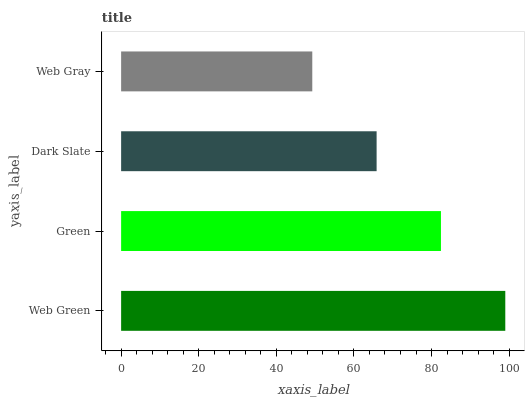Is Web Gray the minimum?
Answer yes or no. Yes. Is Web Green the maximum?
Answer yes or no. Yes. Is Green the minimum?
Answer yes or no. No. Is Green the maximum?
Answer yes or no. No. Is Web Green greater than Green?
Answer yes or no. Yes. Is Green less than Web Green?
Answer yes or no. Yes. Is Green greater than Web Green?
Answer yes or no. No. Is Web Green less than Green?
Answer yes or no. No. Is Green the high median?
Answer yes or no. Yes. Is Dark Slate the low median?
Answer yes or no. Yes. Is Web Gray the high median?
Answer yes or no. No. Is Green the low median?
Answer yes or no. No. 